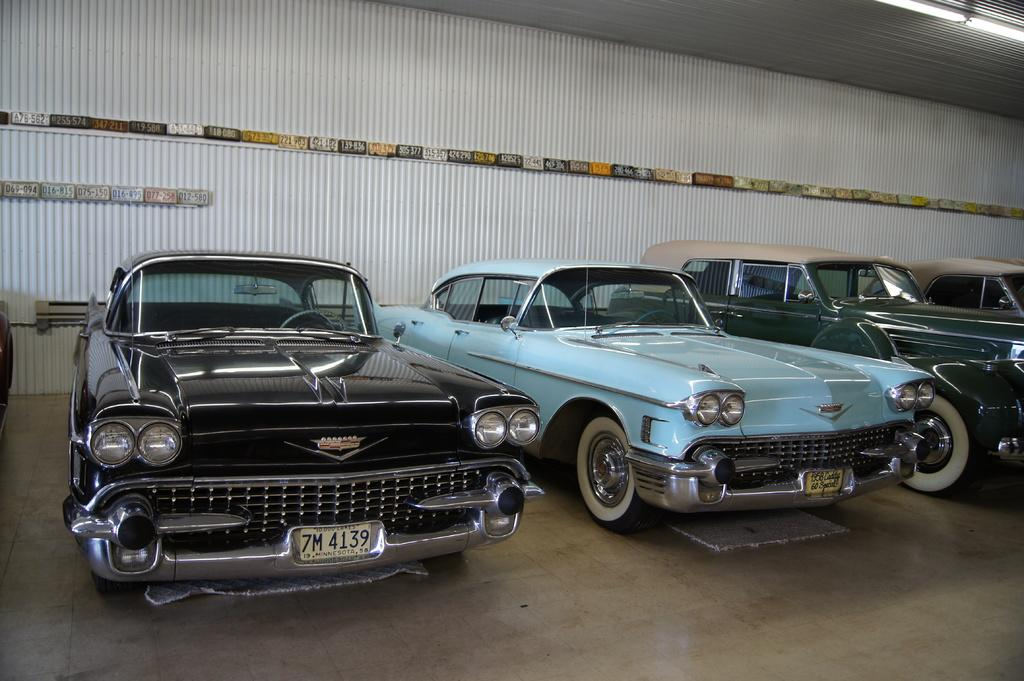What can be seen in the image? There are vehicles in the image. Where are the vehicles located? The vehicles are on a surface. What feature can be observed on the roof of the vehicles? There are light arrangements on the roof of the vehicles. What type of bell can be heard ringing in the image? There is no bell present in the image, and therefore no sound can be heard. 